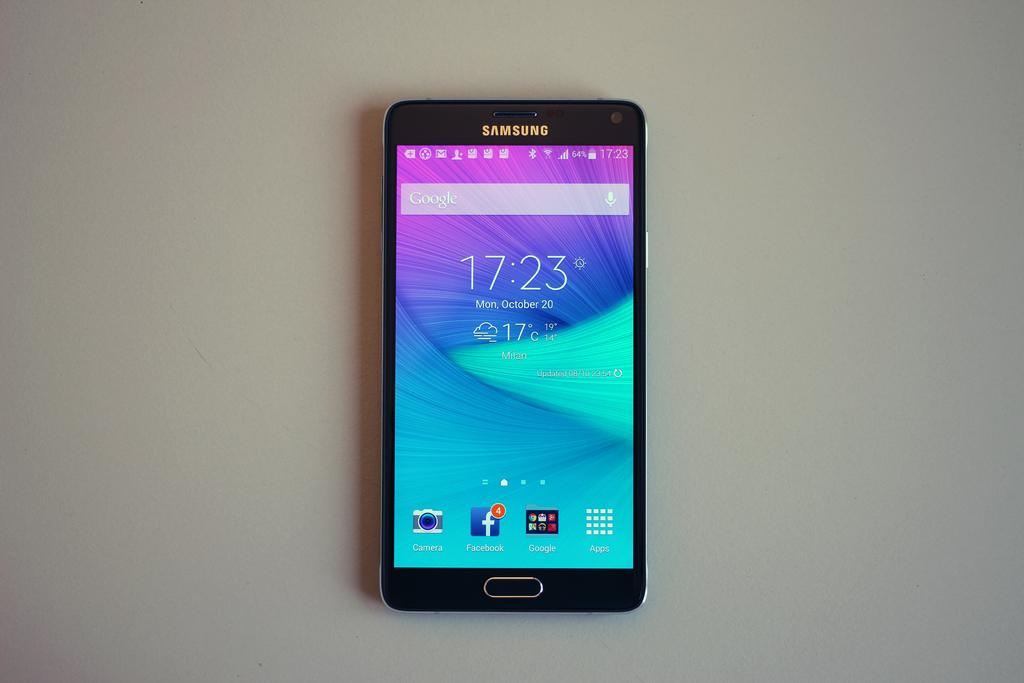What is the brand name of this phone?
Give a very brief answer. Samsung. What time is displayed?
Provide a short and direct response. 17:23. 